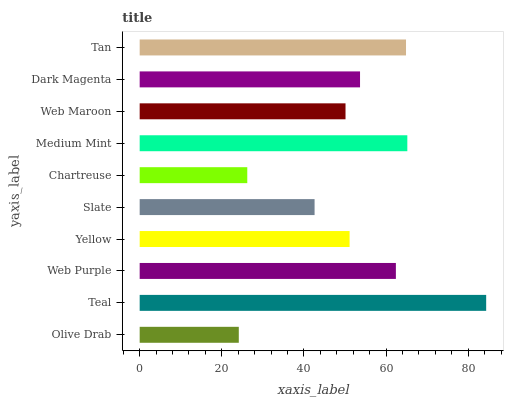Is Olive Drab the minimum?
Answer yes or no. Yes. Is Teal the maximum?
Answer yes or no. Yes. Is Web Purple the minimum?
Answer yes or no. No. Is Web Purple the maximum?
Answer yes or no. No. Is Teal greater than Web Purple?
Answer yes or no. Yes. Is Web Purple less than Teal?
Answer yes or no. Yes. Is Web Purple greater than Teal?
Answer yes or no. No. Is Teal less than Web Purple?
Answer yes or no. No. Is Dark Magenta the high median?
Answer yes or no. Yes. Is Yellow the low median?
Answer yes or no. Yes. Is Medium Mint the high median?
Answer yes or no. No. Is Slate the low median?
Answer yes or no. No. 